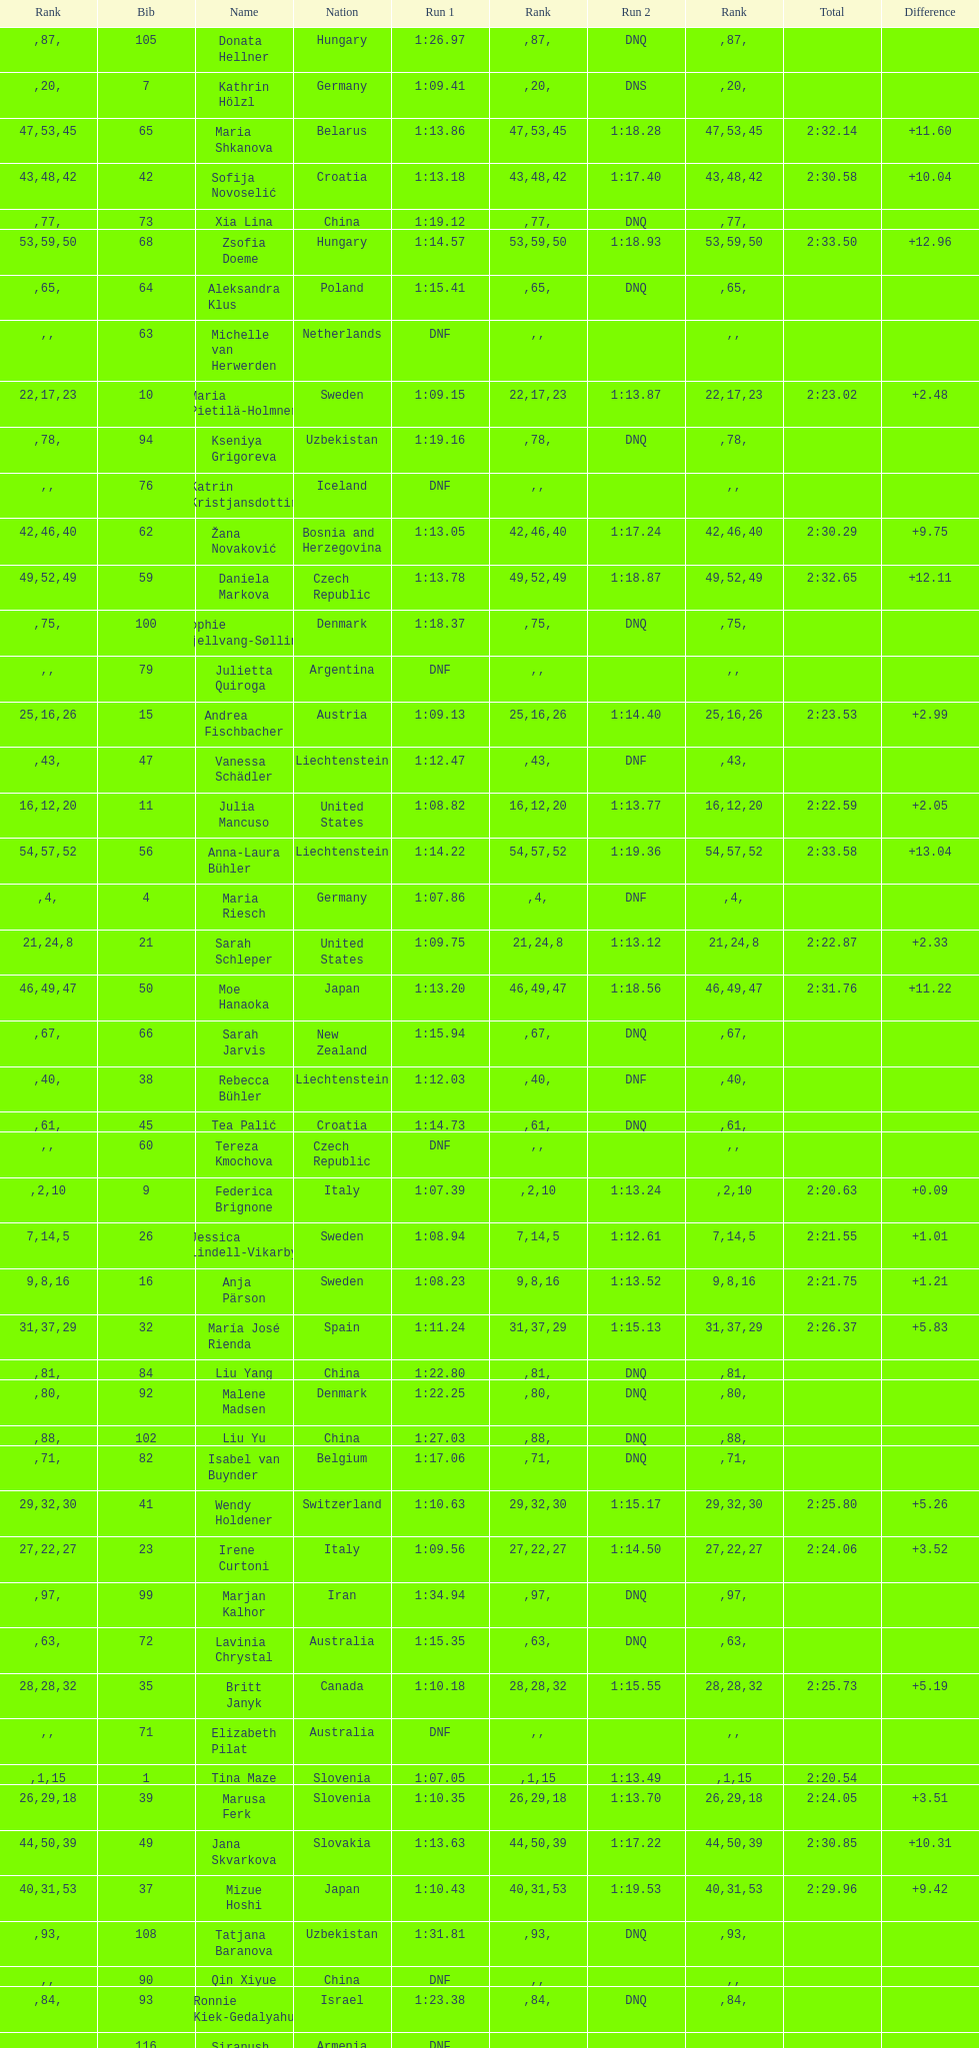What is the name before anja parson? Marlies Schild. 